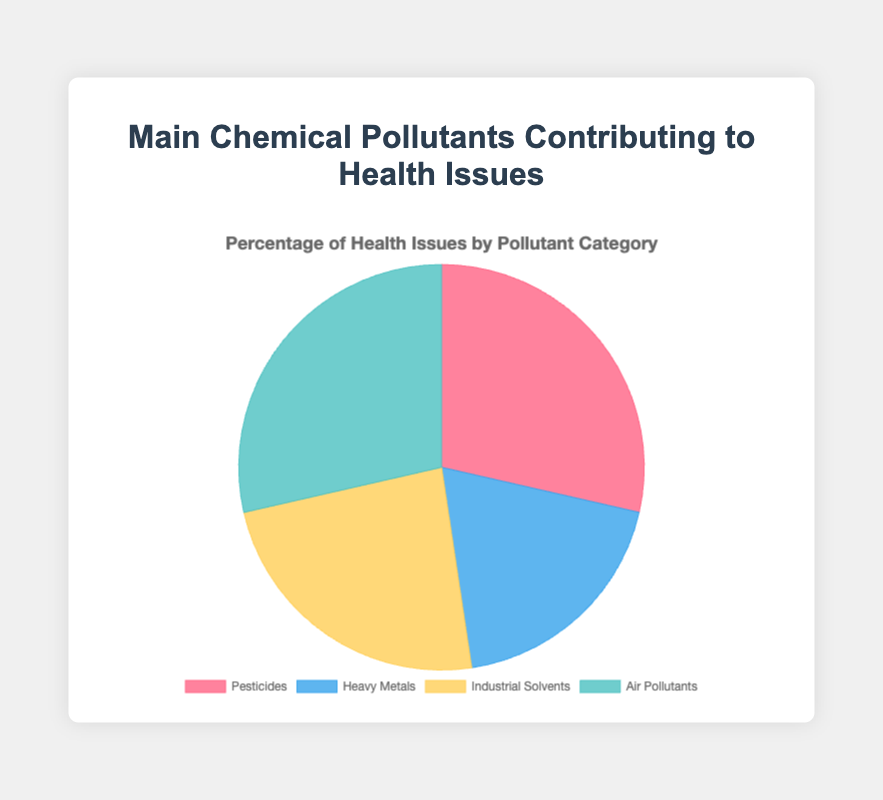What is the largest category of chemical pollutants contributing to health issues? The pie chart shows four categories: Pesticides, Heavy Metals, Industrial Solvents, and Air Pollutants. By comparing the sizes, Air Pollutants have the largest segment.
Answer: Air Pollutants What is the sum of the percentages contributed by Pesticides and Heavy Metals? From the pie chart, Pesticides account for 60% and Heavy Metals for 40%. Adding them together: 60 + 40 = 100%.
Answer: 100% How do the contributions of Industrial Solvents and Air Pollutants compare? Industrial Solvents contribute 50%, while Air Pollutants contribute 60%. Air Pollutants contribute more than Industrial Solvents.
Answer: Air Pollutants contribute more Which category has the smallest contribution to health issues? By observing the smallest segment in the pie chart, Heavy Metals are the category with the smallest percentage.
Answer: Heavy Metals How many more percentage points do Air Pollutants contribute compared to Pesticides? Air Pollutants contribute 60%, and Pesticides contribute 60%. The difference is 0 percentage points.
Answer: 0 percentage points Which segment is represented in red? The red segment in the pie chart represents Pesticides.
Answer: Pesticides Is the sum of the contributions from Industrial Solvents and Air Pollutants greater than 50%? Industrial Solvents contribute 50% and Air Pollutants contribute 60%. The sum is: 50 + 60 = 110%, which is greater than 50%.
Answer: Yes What is the combined percentage of Insecticides and Lead? Insecticides (under Pesticides) contribute 20% and Lead (under Heavy Metals) contributes 20%. Adding them together: 20 + 20 = 40%. This information, however, is inferred from data details not shown on the pie chart.
Answer: 40% 